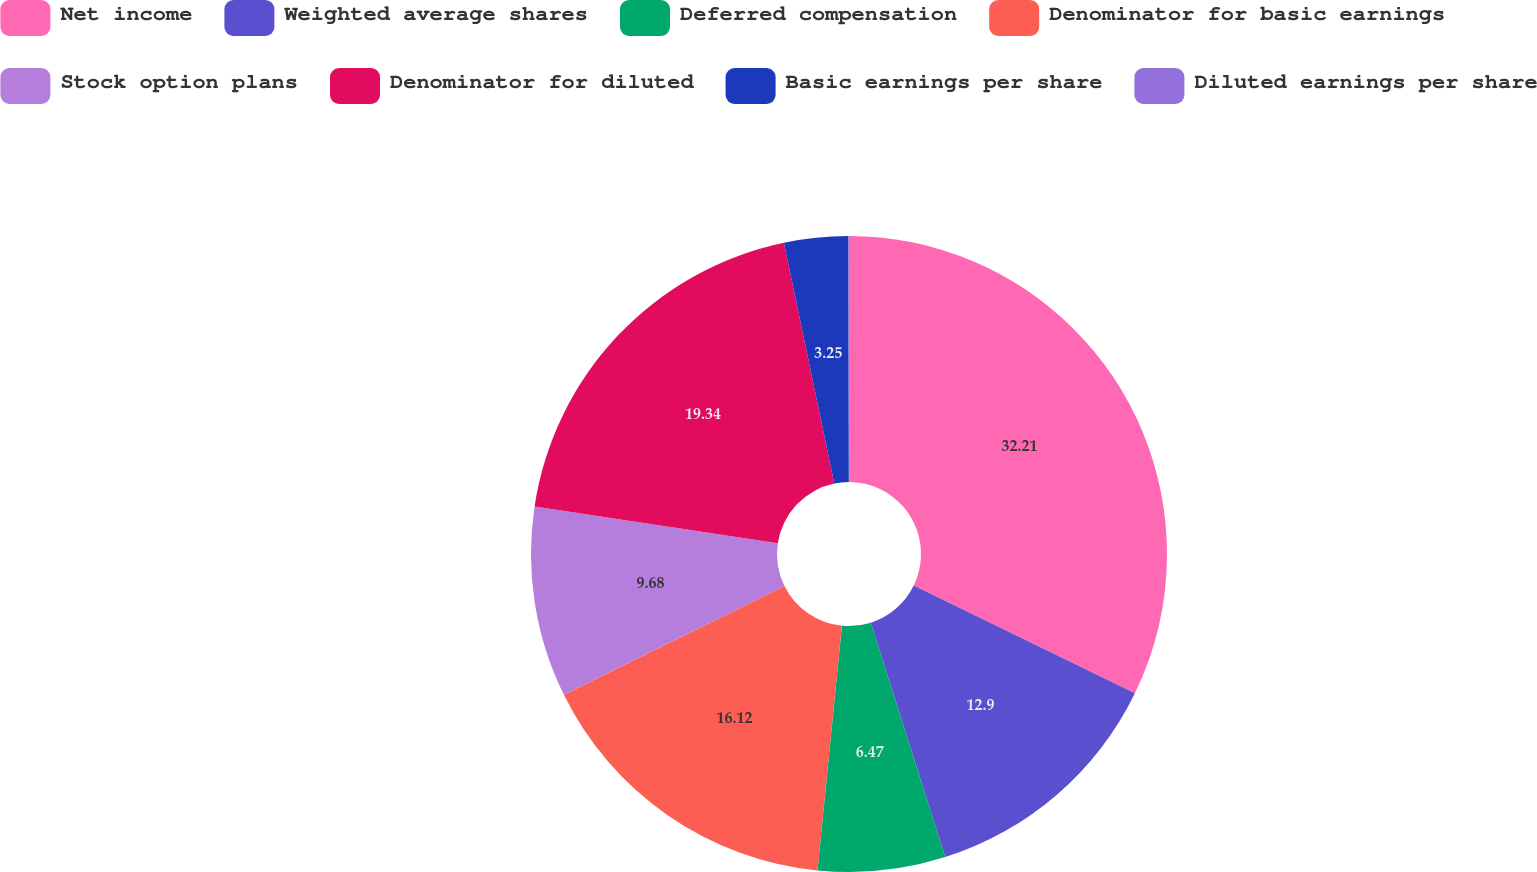Convert chart. <chart><loc_0><loc_0><loc_500><loc_500><pie_chart><fcel>Net income<fcel>Weighted average shares<fcel>Deferred compensation<fcel>Denominator for basic earnings<fcel>Stock option plans<fcel>Denominator for diluted<fcel>Basic earnings per share<fcel>Diluted earnings per share<nl><fcel>32.21%<fcel>12.9%<fcel>6.47%<fcel>16.12%<fcel>9.68%<fcel>19.34%<fcel>3.25%<fcel>0.03%<nl></chart> 